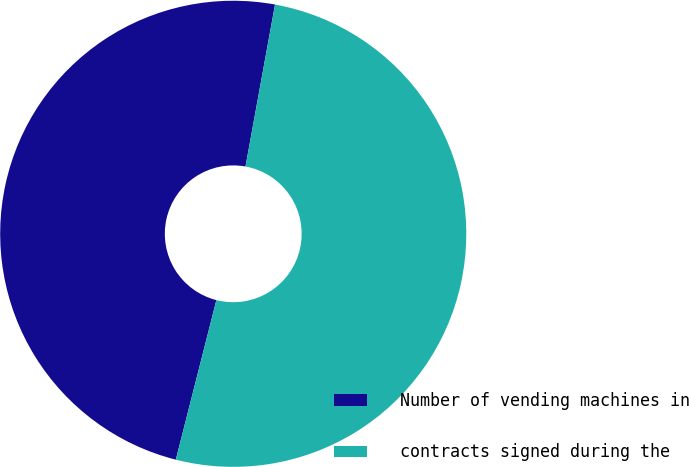Convert chart. <chart><loc_0><loc_0><loc_500><loc_500><pie_chart><fcel>Number of vending machines in<fcel>contracts signed during the<nl><fcel>48.91%<fcel>51.09%<nl></chart> 